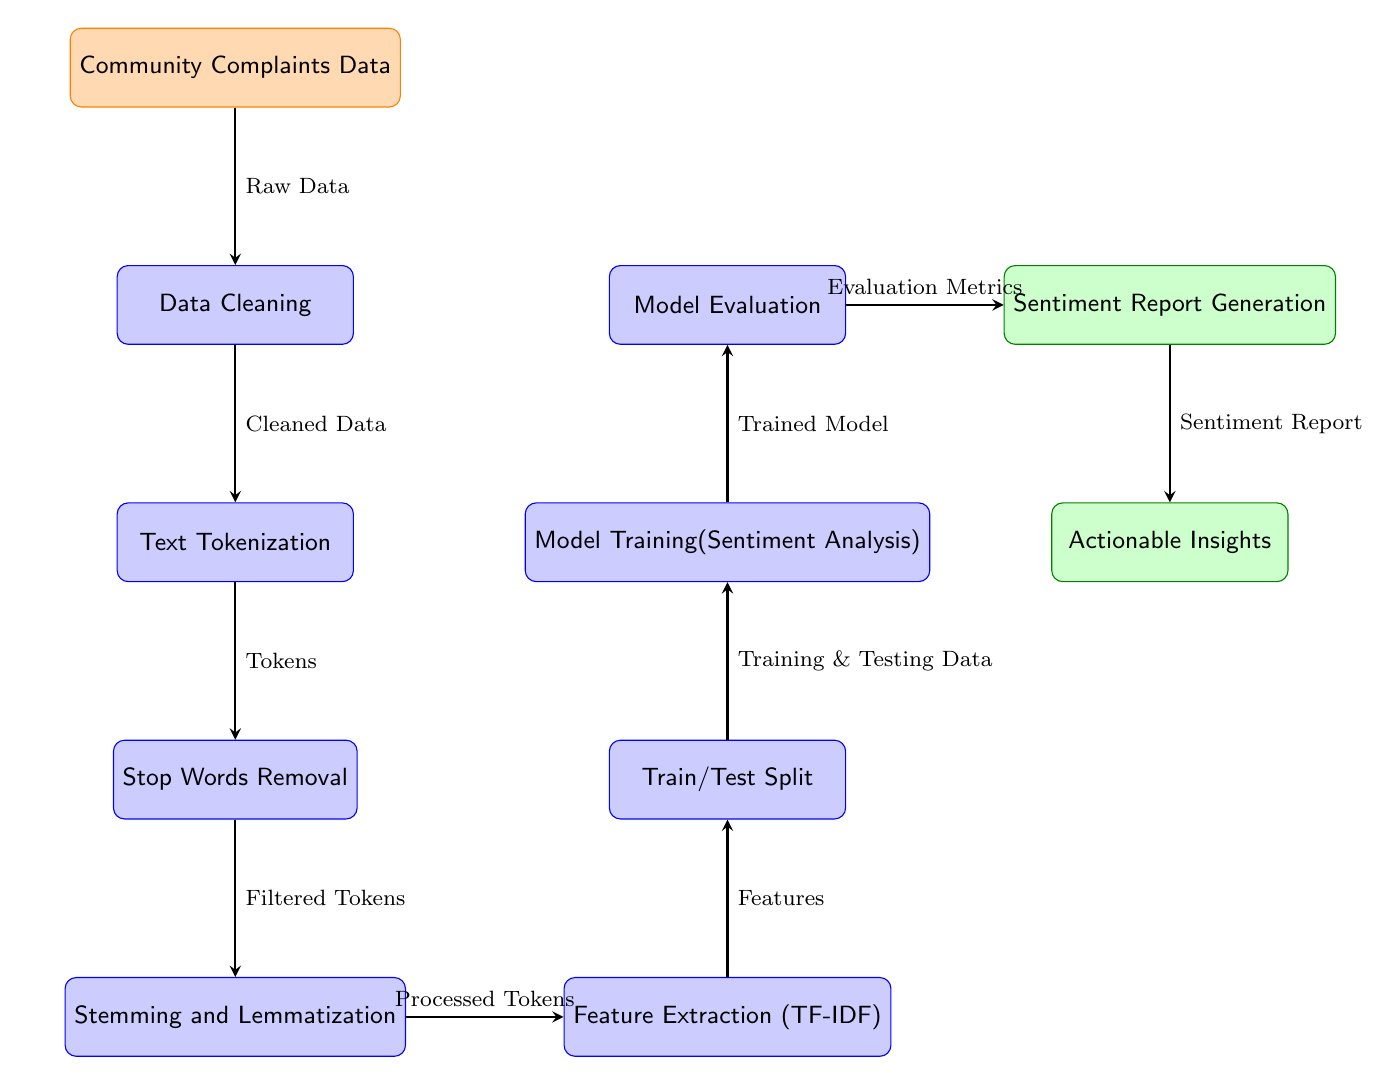What is the input data type for the diagram? The first node in the diagram, labeled "Community Complaints Data," indicates that the input data type is community complaints.
Answer: Community Complaints Data How many processing steps are there in the diagram? Counting the nodes labeled with "process," there are six processing steps outlined in the diagram, namely data cleaning, text tokenization, stop words removal, stemming and lemmatization, feature extraction, and model training.
Answer: Six Which process follows the text tokenization step? The arrow in the diagram shows that the next process after text tokenization is stop words removal, as it's located directly below it.
Answer: Stop Words Removal What document output is generated after model evaluation? The output node that follows the model evaluation step is labeled "Sentiment Report Generation," signifying the generated document output.
Answer: Sentiment Report Generation What is obtained after feature extraction? The feature extraction process yields features that are designated as "Features," which is the output in the diagram following that process.
Answer: Features How is the cleaned data used in the diagram? The cleaned data is passed on from the data cleaning process to the text tokenization process as indicated by the arrow connecting those two nodes.
Answer: Text Tokenization Which two outputs are produced at the end of the diagram? The final two output nodes are "Sentiment Report Generation" and "Actionable Insights," showing the dual outputs that arise from the sentiment analysis.
Answer: Sentiment Report Generation, Actionable Insights What is the purpose of stemming and lemmatization in the process? Stemming and lemmatization are intended to reduce words to their base or root forms, which is illustrated by its label, "Stemming and Lemmatization," indicating this process's role in preparing the text.
Answer: Processed Tokens What is the purpose of the train/test split step? The purpose of the train/test split step is to separate the data into subsets for training and testing, as indicated by its label "Train/Test Split."
Answer: Training & Testing Data 